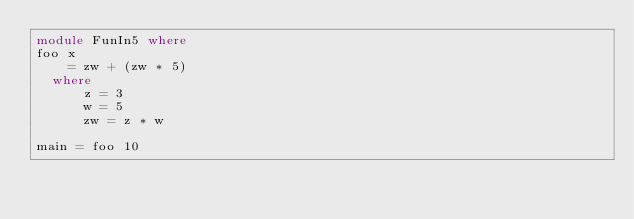<code> <loc_0><loc_0><loc_500><loc_500><_Haskell_>module FunIn5 where
foo x
    = zw + (zw * 5)
  where
      z = 3
      w = 5
      zw = z * w
 
main = foo 10
 </code> 